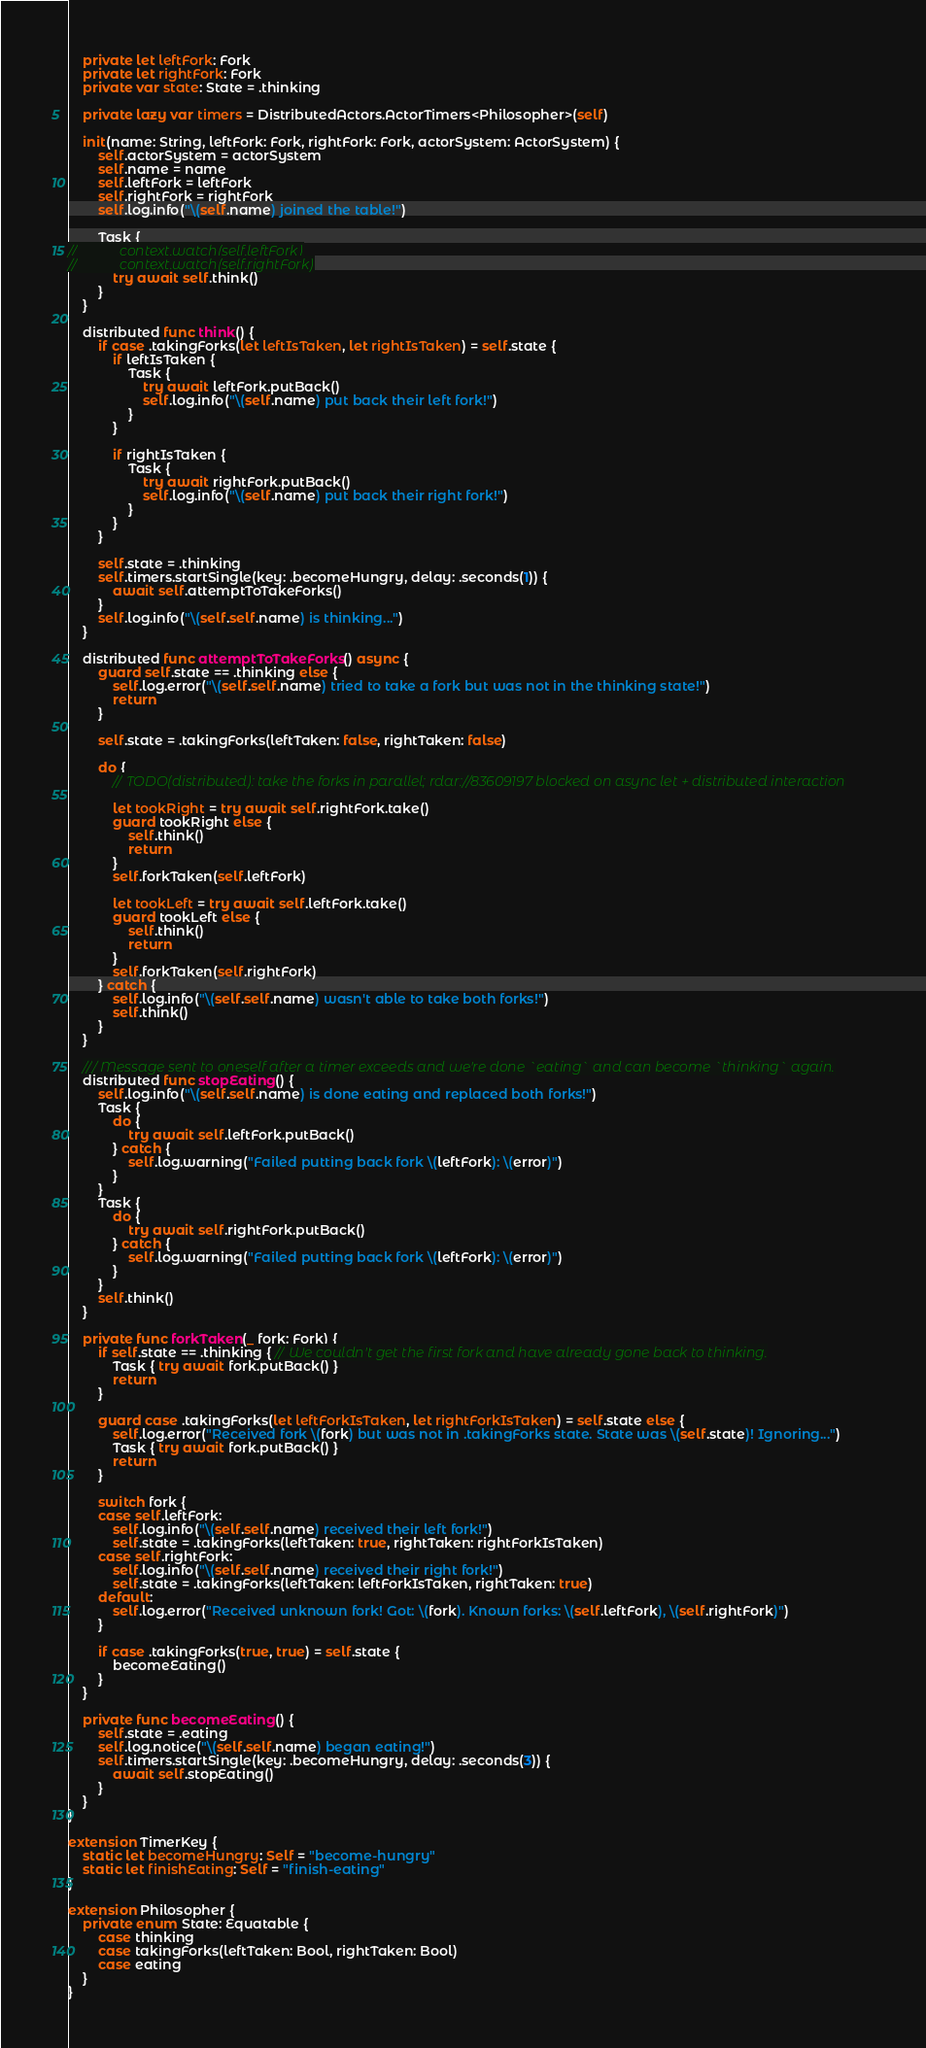<code> <loc_0><loc_0><loc_500><loc_500><_Swift_>
    private let leftFork: Fork
    private let rightFork: Fork
    private var state: State = .thinking

    private lazy var timers = DistributedActors.ActorTimers<Philosopher>(self)

    init(name: String, leftFork: Fork, rightFork: Fork, actorSystem: ActorSystem) {
        self.actorSystem = actorSystem
        self.name = name
        self.leftFork = leftFork
        self.rightFork = rightFork
        self.log.info("\(self.name) joined the table!")

        Task {
//            context.watch(self.leftFork)
//            context.watch(self.rightFork)
            try await self.think()
        }
    }

    distributed func think() {
        if case .takingForks(let leftIsTaken, let rightIsTaken) = self.state {
            if leftIsTaken {
                Task {
                    try await leftFork.putBack()
                    self.log.info("\(self.name) put back their left fork!")
                }
            }

            if rightIsTaken {
                Task {
                    try await rightFork.putBack()
                    self.log.info("\(self.name) put back their right fork!")
                }
            }
        }

        self.state = .thinking
        self.timers.startSingle(key: .becomeHungry, delay: .seconds(1)) {
            await self.attemptToTakeForks()
        }
        self.log.info("\(self.self.name) is thinking...")
    }

    distributed func attemptToTakeForks() async {
        guard self.state == .thinking else {
            self.log.error("\(self.self.name) tried to take a fork but was not in the thinking state!")
            return
        }

        self.state = .takingForks(leftTaken: false, rightTaken: false)

        do {
            // TODO(distributed): take the forks in parallel; rdar://83609197 blocked on async let + distributed interaction

            let tookRight = try await self.rightFork.take()
            guard tookRight else {
                self.think()
                return
            }
            self.forkTaken(self.leftFork)

            let tookLeft = try await self.leftFork.take()
            guard tookLeft else {
                self.think()
                return
            }
            self.forkTaken(self.rightFork)
        } catch {
            self.log.info("\(self.self.name) wasn't able to take both forks!")
            self.think()
        }
    }

    /// Message sent to oneself after a timer exceeds and we're done `eating` and can become `thinking` again.
    distributed func stopEating() {
        self.log.info("\(self.self.name) is done eating and replaced both forks!")
        Task {
            do {
                try await self.leftFork.putBack()
            } catch {
                self.log.warning("Failed putting back fork \(leftFork): \(error)")
            }
        }
        Task {
            do {
                try await self.rightFork.putBack()
            } catch {
                self.log.warning("Failed putting back fork \(leftFork): \(error)")
            }
        }
        self.think()
    }

    private func forkTaken(_ fork: Fork) {
        if self.state == .thinking { // We couldn't get the first fork and have already gone back to thinking.
            Task { try await fork.putBack() }
            return
        }

        guard case .takingForks(let leftForkIsTaken, let rightForkIsTaken) = self.state else {
            self.log.error("Received fork \(fork) but was not in .takingForks state. State was \(self.state)! Ignoring...")
            Task { try await fork.putBack() }
            return
        }

        switch fork {
        case self.leftFork:
            self.log.info("\(self.self.name) received their left fork!")
            self.state = .takingForks(leftTaken: true, rightTaken: rightForkIsTaken)
        case self.rightFork:
            self.log.info("\(self.self.name) received their right fork!")
            self.state = .takingForks(leftTaken: leftForkIsTaken, rightTaken: true)
        default:
            self.log.error("Received unknown fork! Got: \(fork). Known forks: \(self.leftFork), \(self.rightFork)")
        }

        if case .takingForks(true, true) = self.state {
            becomeEating()
        }
    }

    private func becomeEating() {
        self.state = .eating
        self.log.notice("\(self.self.name) began eating!")
        self.timers.startSingle(key: .becomeHungry, delay: .seconds(3)) {
            await self.stopEating()
        }
    }
}

extension TimerKey {
    static let becomeHungry: Self = "become-hungry"
    static let finishEating: Self = "finish-eating"
}

extension Philosopher {
    private enum State: Equatable {
        case thinking
        case takingForks(leftTaken: Bool, rightTaken: Bool)
        case eating
    }
}
</code> 